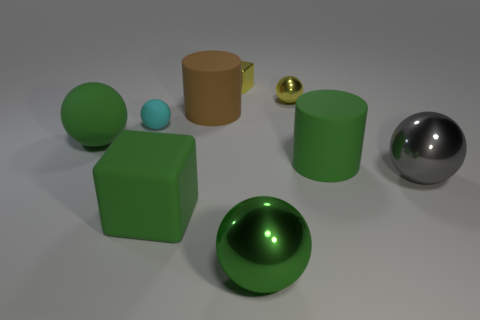Subtract 1 balls. How many balls are left? 4 Subtract all gray balls. How many balls are left? 4 Subtract all big gray balls. How many balls are left? 4 Subtract all purple spheres. Subtract all yellow cylinders. How many spheres are left? 5 Add 1 tiny red cylinders. How many objects exist? 10 Subtract all cubes. How many objects are left? 7 Subtract all rubber objects. Subtract all large gray metallic things. How many objects are left? 3 Add 8 gray metallic objects. How many gray metallic objects are left? 9 Add 9 big red metallic cubes. How many big red metallic cubes exist? 9 Subtract 0 cyan blocks. How many objects are left? 9 